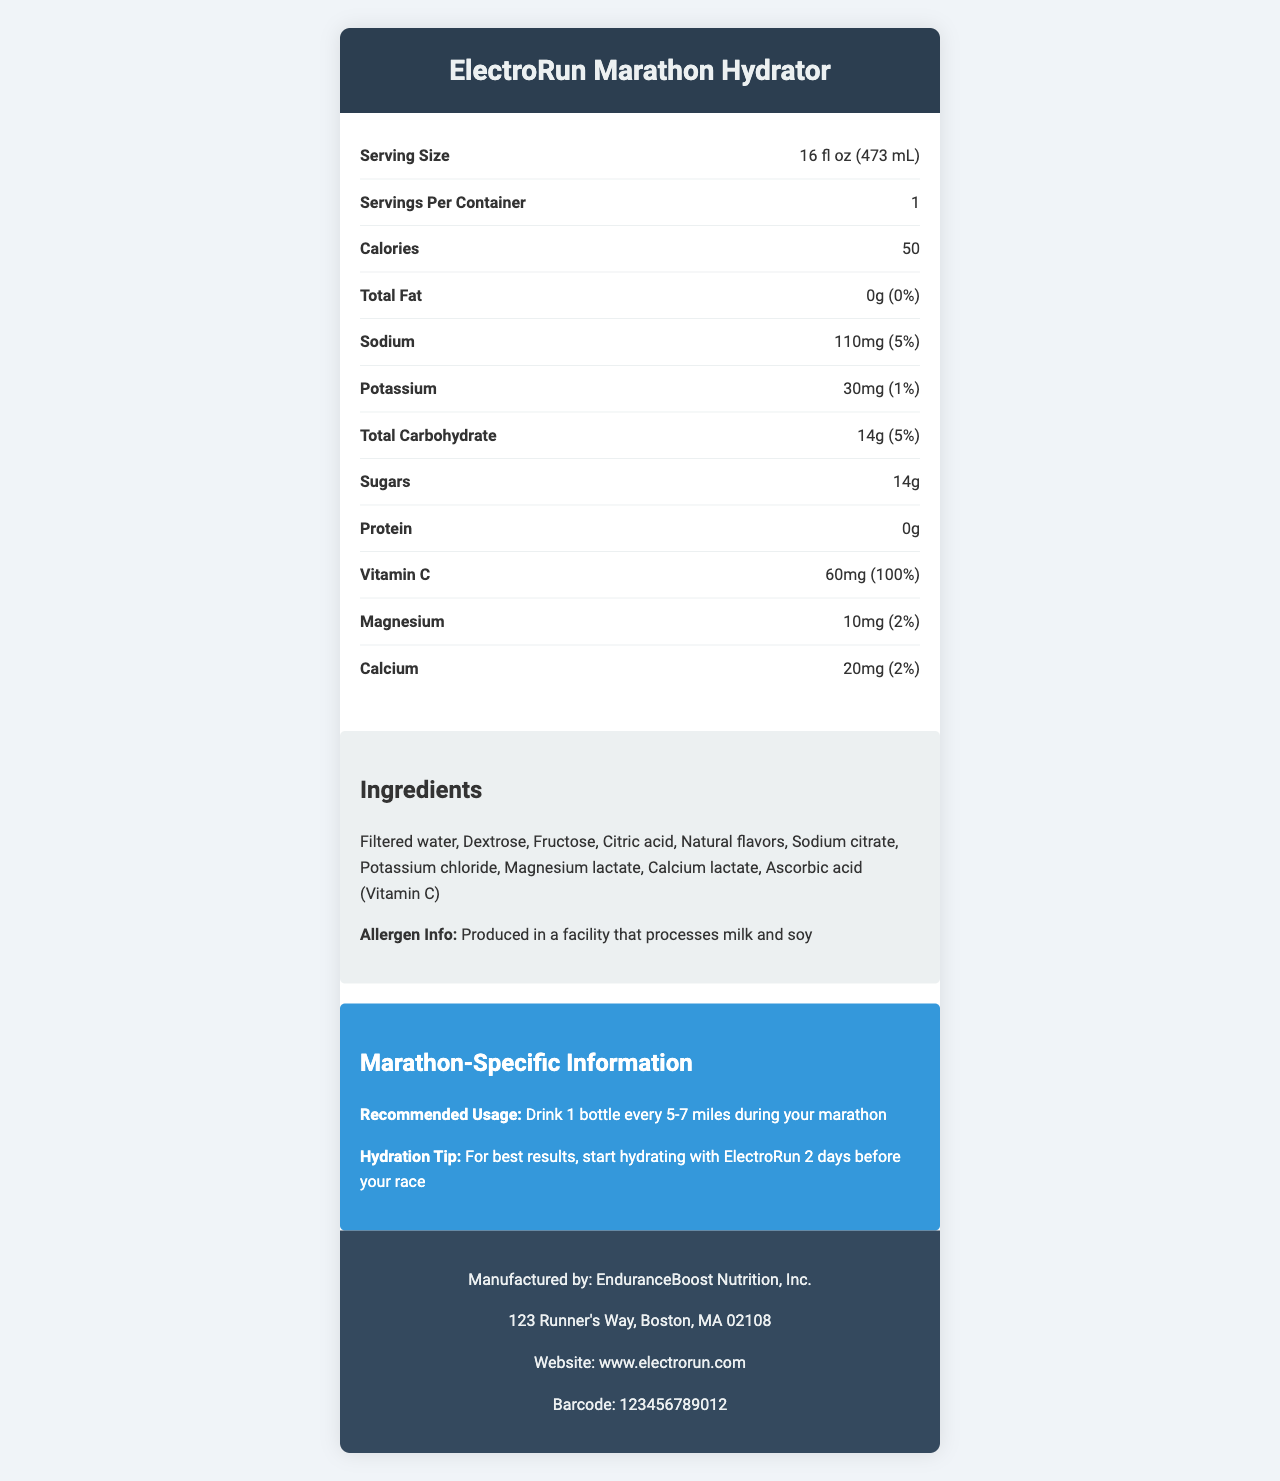what is the serving size? The document specifies the serving size as "16 fl oz (473 mL)" in the nutrition facts section.
Answer: 16 fl oz (473 mL) how many calories does one serving contain? The document lists the number of calories per serving as 50.
Answer: 50 what is the amount of sodium per serving? The sodium content per serving is indicated as 110mg in the nutrition facts.
Answer: 110mg how much sugar is in one serving? The nutrition facts state that there are 14g of sugars in one serving.
Answer: 14g what is the daily value percentage for vitamin C? The document shows that the vitamin C daily value percentage is 100%.
Answer: 100% how many servings are there per container? The nutrition facts label indicates there is 1 serving per container.
Answer: 1 what are the main ingredients in the drink? The ingredients list these items in order.
Answer: Filtered water, Dextrose, Fructose, Citric acid, Natural flavors, Sodium citrate, Potassium chloride, Magnesium lactate, Calcium lactate, Ascorbic acid (Vitamin C) where is the manufacturer located? The manufacturer’s address is provided in the footer section of the document.
Answer: 123 Runner's Way, Boston, MA 02108 which of the following nutrients is not present in the drink? A. Protein, B. Sodium, C. Potassium, D. Total carbohydrate The nutrition facts show 0g of protein, indicating it is not present in the drink.
Answer: A. Protein how many grams of protein are in the drink? A. 0g B. 1g C. 5g D. 10g The nutrition facts label indicates 0g of protein per serving.
Answer: A. 0g should someone with a milk allergy be cautious with this product? (yes/no) The allergen info states that the product is produced in a facility that processes milk and soy.
Answer: Yes summarize the main idea of the document The document serves to inform consumers about the nutritional content, ingredients, allergen information, manufacturer details, and specific usage recommendations for the ElectroRun Marathon Hydrator, targeting marathon runners.
Answer: The document provides comprehensive nutrition facts, ingredients, allergen information, and manufacturer details for the ElectroRun Marathon Hydrator sports drink. It offers specific guidelines for marathon usage and hydration tips for runners. how many grams of potassium are there per serving? The amount of potassium is provided in milligrams (30mg) in the document, not grams. Adjusting for units would require extra information not visually present in the document.
Answer: Not enough information 